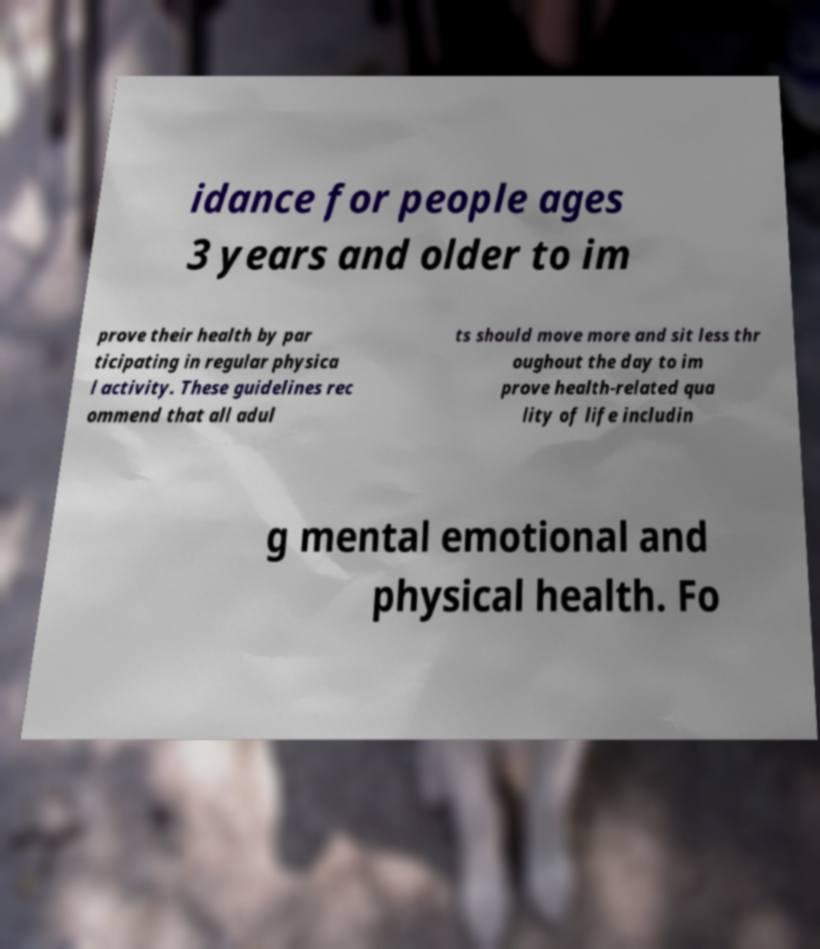For documentation purposes, I need the text within this image transcribed. Could you provide that? idance for people ages 3 years and older to im prove their health by par ticipating in regular physica l activity. These guidelines rec ommend that all adul ts should move more and sit less thr oughout the day to im prove health-related qua lity of life includin g mental emotional and physical health. Fo 